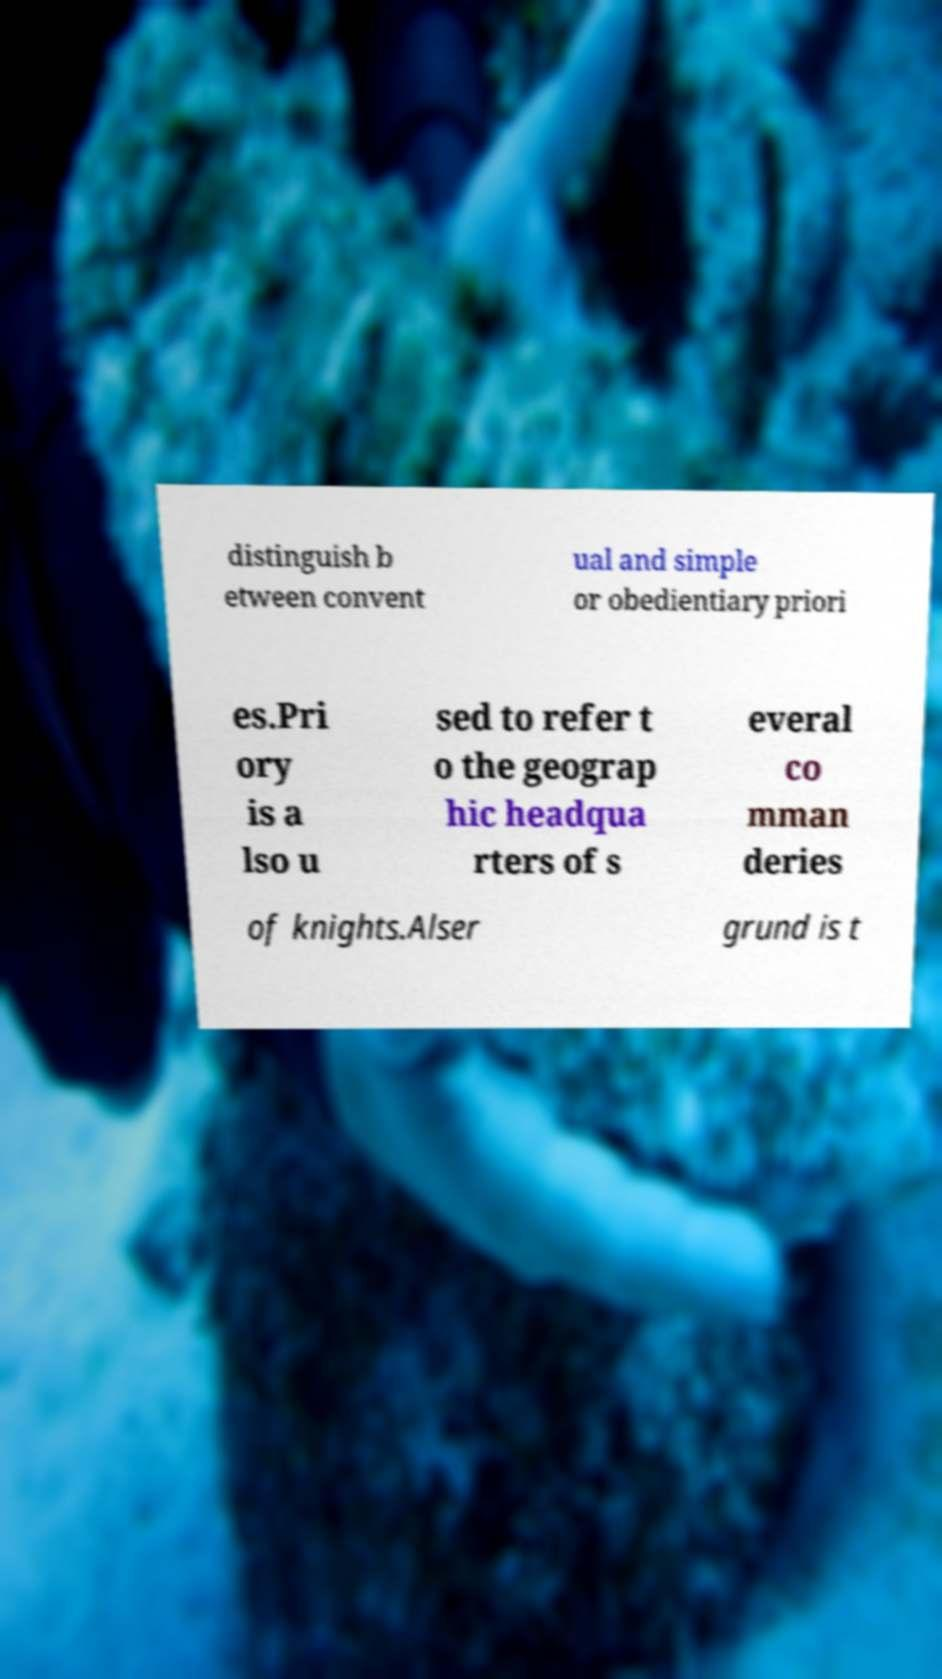Please read and relay the text visible in this image. What does it say? distinguish b etween convent ual and simple or obedientiary priori es.Pri ory is a lso u sed to refer t o the geograp hic headqua rters of s everal co mman deries of knights.Alser grund is t 